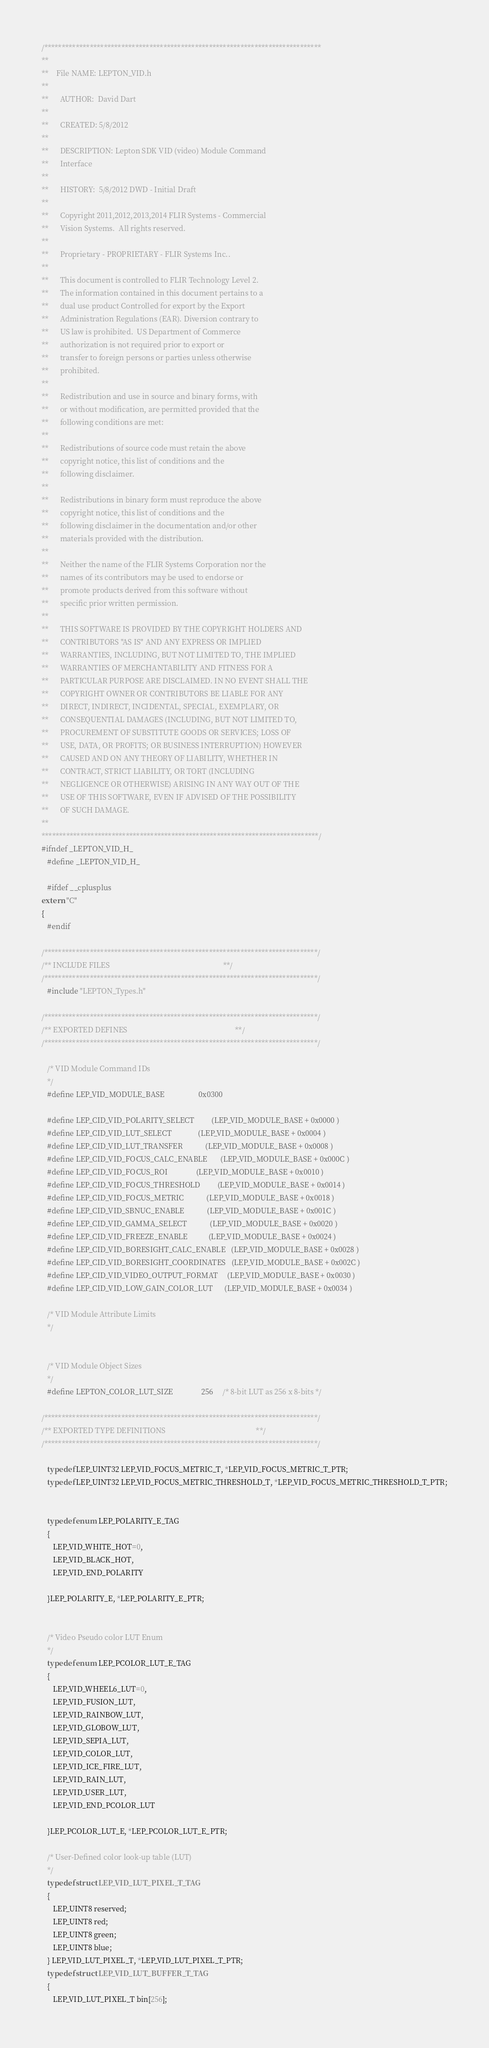<code> <loc_0><loc_0><loc_500><loc_500><_C_>/*******************************************************************************
**
**    File NAME: LEPTON_VID.h
**
**      AUTHOR:  David Dart
**
**      CREATED: 5/8/2012
**  
**      DESCRIPTION: Lepton SDK VID (video) Module Command
**      Interface
**
**      HISTORY:  5/8/2012 DWD - Initial Draft 
**
**      Copyright 2011,2012,2013,2014 FLIR Systems - Commercial
**      Vision Systems.  All rights reserved.
**
**      Proprietary - PROPRIETARY - FLIR Systems Inc..
**  
**      This document is controlled to FLIR Technology Level 2.
**      The information contained in this document pertains to a
**      dual use product Controlled for export by the Export
**      Administration Regulations (EAR). Diversion contrary to
**      US law is prohibited.  US Department of Commerce
**      authorization is not required prior to export or
**      transfer to foreign persons or parties unless otherwise
**      prohibited.
**
**      Redistribution and use in source and binary forms, with
**      or without modification, are permitted provided that the
**      following conditions are met:
**
**      Redistributions of source code must retain the above
**      copyright notice, this list of conditions and the
**      following disclaimer.
**
**      Redistributions in binary form must reproduce the above
**      copyright notice, this list of conditions and the
**      following disclaimer in the documentation and/or other
**      materials provided with the distribution.
**
**      Neither the name of the FLIR Systems Corporation nor the
**      names of its contributors may be used to endorse or
**      promote products derived from this software without
**      specific prior written permission.
**
**      THIS SOFTWARE IS PROVIDED BY THE COPYRIGHT HOLDERS AND
**      CONTRIBUTORS "AS IS" AND ANY EXPRESS OR IMPLIED
**      WARRANTIES, INCLUDING, BUT NOT LIMITED TO, THE IMPLIED
**      WARRANTIES OF MERCHANTABILITY AND FITNESS FOR A
**      PARTICULAR PURPOSE ARE DISCLAIMED. IN NO EVENT SHALL THE
**      COPYRIGHT OWNER OR CONTRIBUTORS BE LIABLE FOR ANY
**      DIRECT, INDIRECT, INCIDENTAL, SPECIAL, EXEMPLARY, OR
**      CONSEQUENTIAL DAMAGES (INCLUDING, BUT NOT LIMITED TO,
**      PROCUREMENT OF SUBSTITUTE GOODS OR SERVICES; LOSS OF
**      USE, DATA, OR PROFITS; OR BUSINESS INTERRUPTION) HOWEVER
**      CAUSED AND ON ANY THEORY OF LIABILITY, WHETHER IN
**      CONTRACT, STRICT LIABILITY, OR TORT (INCLUDING
**      NEGLIGENCE OR OTHERWISE) ARISING IN ANY WAY OUT OF THE
**      USE OF THIS SOFTWARE, EVEN IF ADVISED OF THE POSSIBILITY
**      OF SUCH DAMAGE.
**
*******************************************************************************/
#ifndef _LEPTON_VID_H_ 
   #define _LEPTON_VID_H_

   #ifdef __cplusplus
extern "C"
{
   #endif

/******************************************************************************/
/** INCLUDE FILES                                                            **/
/******************************************************************************/
   #include "LEPTON_Types.h"

/******************************************************************************/
/** EXPORTED DEFINES                                                         **/
/******************************************************************************/

   /* VID Module Command IDs
   */ 
   #define LEP_VID_MODULE_BASE                  0x0300

   #define LEP_CID_VID_POLARITY_SELECT         (LEP_VID_MODULE_BASE + 0x0000 )
   #define LEP_CID_VID_LUT_SELECT              (LEP_VID_MODULE_BASE + 0x0004 )
   #define LEP_CID_VID_LUT_TRANSFER            (LEP_VID_MODULE_BASE + 0x0008 )
   #define LEP_CID_VID_FOCUS_CALC_ENABLE       (LEP_VID_MODULE_BASE + 0x000C )
   #define LEP_CID_VID_FOCUS_ROI               (LEP_VID_MODULE_BASE + 0x0010 )
   #define LEP_CID_VID_FOCUS_THRESHOLD         (LEP_VID_MODULE_BASE + 0x0014 )
   #define LEP_CID_VID_FOCUS_METRIC            (LEP_VID_MODULE_BASE + 0x0018 )
   #define LEP_CID_VID_SBNUC_ENABLE            (LEP_VID_MODULE_BASE + 0x001C )
   #define LEP_CID_VID_GAMMA_SELECT            (LEP_VID_MODULE_BASE + 0x0020 )
   #define LEP_CID_VID_FREEZE_ENABLE           (LEP_VID_MODULE_BASE + 0x0024 )
   #define LEP_CID_VID_BORESIGHT_CALC_ENABLE   (LEP_VID_MODULE_BASE + 0x0028 )
   #define LEP_CID_VID_BORESIGHT_COORDINATES   (LEP_VID_MODULE_BASE + 0x002C )
   #define LEP_CID_VID_VIDEO_OUTPUT_FORMAT     (LEP_VID_MODULE_BASE + 0x0030 )
   #define LEP_CID_VID_LOW_GAIN_COLOR_LUT      (LEP_VID_MODULE_BASE + 0x0034 )

   /* VID Module Attribute Limits
   */ 


   /* VID Module Object Sizes
   */ 
   #define LEPTON_COLOR_LUT_SIZE               256     /* 8-bit LUT as 256 x 8-bits */

/******************************************************************************/
/** EXPORTED TYPE DEFINITIONS                                                **/
/******************************************************************************/

   typedef LEP_UINT32 LEP_VID_FOCUS_METRIC_T, *LEP_VID_FOCUS_METRIC_T_PTR;
   typedef LEP_UINT32 LEP_VID_FOCUS_METRIC_THRESHOLD_T, *LEP_VID_FOCUS_METRIC_THRESHOLD_T_PTR;


   typedef enum LEP_POLARITY_E_TAG
   {
      LEP_VID_WHITE_HOT=0,
      LEP_VID_BLACK_HOT,
      LEP_VID_END_POLARITY

   }LEP_POLARITY_E, *LEP_POLARITY_E_PTR;


   /* Video Pseudo color LUT Enum
   */
   typedef enum LEP_PCOLOR_LUT_E_TAG
   {
      LEP_VID_WHEEL6_LUT=0,
      LEP_VID_FUSION_LUT,
      LEP_VID_RAINBOW_LUT,
      LEP_VID_GLOBOW_LUT,
      LEP_VID_SEPIA_LUT,
      LEP_VID_COLOR_LUT,
      LEP_VID_ICE_FIRE_LUT,
      LEP_VID_RAIN_LUT,
      LEP_VID_USER_LUT,
      LEP_VID_END_PCOLOR_LUT

   }LEP_PCOLOR_LUT_E, *LEP_PCOLOR_LUT_E_PTR;

   /* User-Defined color look-up table (LUT)
   */ 
   typedef struct LEP_VID_LUT_PIXEL_T_TAG
   {
      LEP_UINT8 reserved;
      LEP_UINT8 red;
      LEP_UINT8 green;
      LEP_UINT8 blue;
   } LEP_VID_LUT_PIXEL_T, *LEP_VID_LUT_PIXEL_T_PTR;
   typedef struct LEP_VID_LUT_BUFFER_T_TAG
   {
      LEP_VID_LUT_PIXEL_T bin[256];</code> 